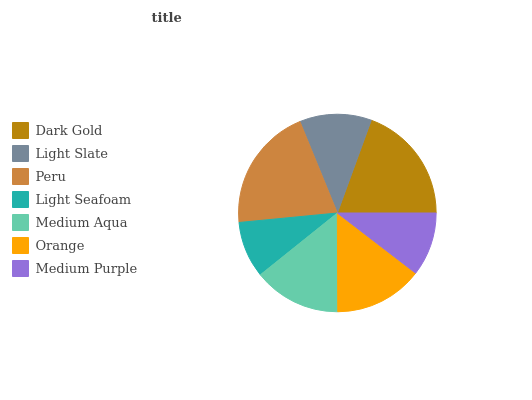Is Light Seafoam the minimum?
Answer yes or no. Yes. Is Peru the maximum?
Answer yes or no. Yes. Is Light Slate the minimum?
Answer yes or no. No. Is Light Slate the maximum?
Answer yes or no. No. Is Dark Gold greater than Light Slate?
Answer yes or no. Yes. Is Light Slate less than Dark Gold?
Answer yes or no. Yes. Is Light Slate greater than Dark Gold?
Answer yes or no. No. Is Dark Gold less than Light Slate?
Answer yes or no. No. Is Medium Aqua the high median?
Answer yes or no. Yes. Is Medium Aqua the low median?
Answer yes or no. Yes. Is Light Slate the high median?
Answer yes or no. No. Is Peru the low median?
Answer yes or no. No. 